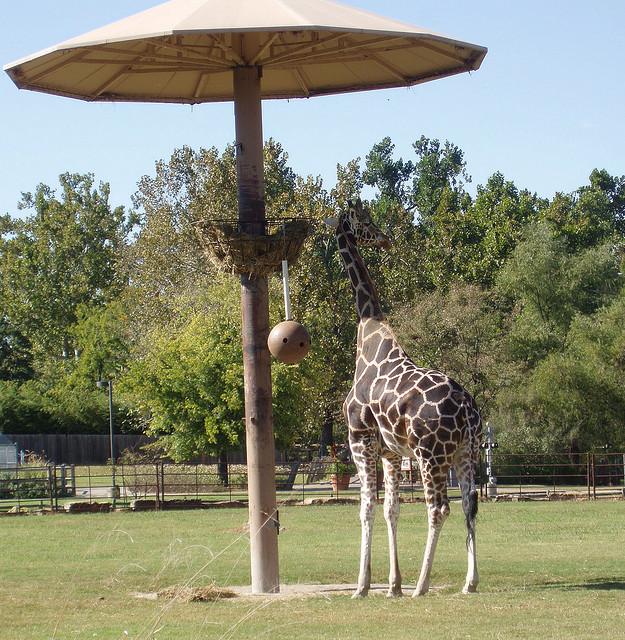Is this giraffe in the wild?
Answer briefly. No. Was this giraffe just born?
Answer briefly. No. How many giraffes are seen?
Concise answer only. 1. 